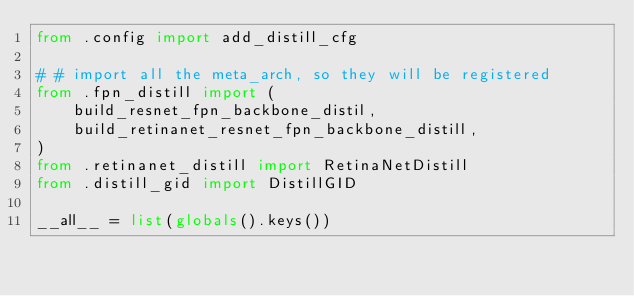Convert code to text. <code><loc_0><loc_0><loc_500><loc_500><_Python_>from .config import add_distill_cfg

# # import all the meta_arch, so they will be registered
from .fpn_distill import (
    build_resnet_fpn_backbone_distil,
    build_retinanet_resnet_fpn_backbone_distill,
)
from .retinanet_distill import RetinaNetDistill
from .distill_gid import DistillGID

__all__ = list(globals().keys())</code> 